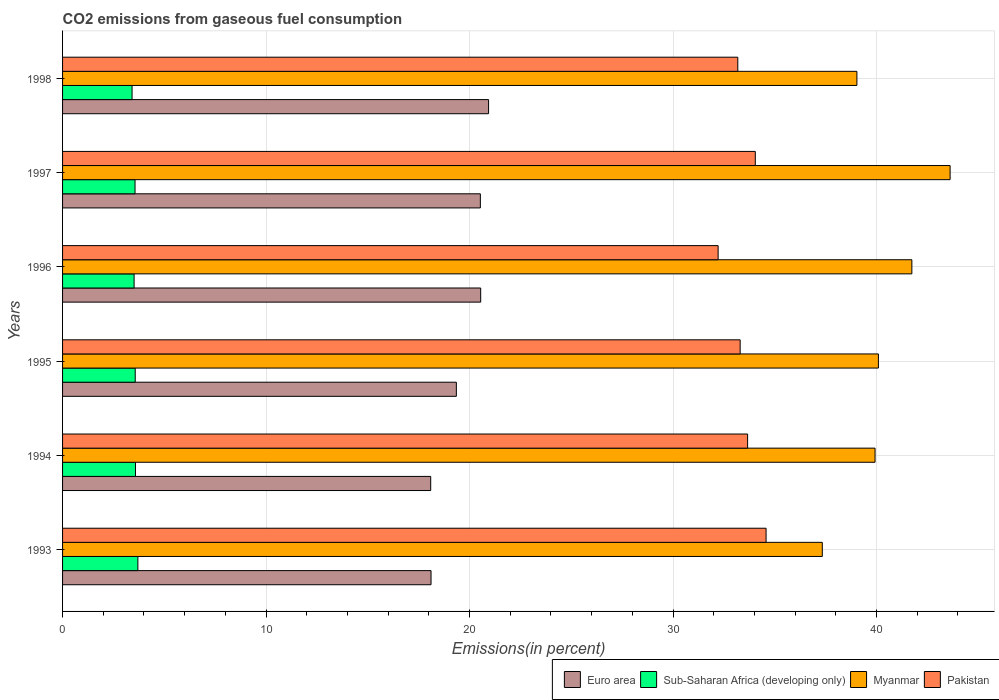Are the number of bars per tick equal to the number of legend labels?
Give a very brief answer. Yes. How many bars are there on the 1st tick from the top?
Provide a succinct answer. 4. What is the total CO2 emitted in Myanmar in 1995?
Offer a very short reply. 40.09. Across all years, what is the maximum total CO2 emitted in Sub-Saharan Africa (developing only)?
Your answer should be very brief. 3.7. Across all years, what is the minimum total CO2 emitted in Euro area?
Offer a very short reply. 18.09. In which year was the total CO2 emitted in Euro area maximum?
Provide a succinct answer. 1998. What is the total total CO2 emitted in Pakistan in the graph?
Your answer should be compact. 200.99. What is the difference between the total CO2 emitted in Myanmar in 1997 and that in 1998?
Keep it short and to the point. 4.58. What is the difference between the total CO2 emitted in Pakistan in 1996 and the total CO2 emitted in Euro area in 1997?
Make the answer very short. 11.69. What is the average total CO2 emitted in Myanmar per year?
Provide a short and direct response. 40.29. In the year 1996, what is the difference between the total CO2 emitted in Sub-Saharan Africa (developing only) and total CO2 emitted in Myanmar?
Keep it short and to the point. -38.22. What is the ratio of the total CO2 emitted in Sub-Saharan Africa (developing only) in 1994 to that in 1997?
Give a very brief answer. 1.01. What is the difference between the highest and the second highest total CO2 emitted in Pakistan?
Ensure brevity in your answer.  0.53. What is the difference between the highest and the lowest total CO2 emitted in Pakistan?
Keep it short and to the point. 2.36. In how many years, is the total CO2 emitted in Myanmar greater than the average total CO2 emitted in Myanmar taken over all years?
Keep it short and to the point. 2. Is the sum of the total CO2 emitted in Pakistan in 1995 and 1998 greater than the maximum total CO2 emitted in Sub-Saharan Africa (developing only) across all years?
Provide a succinct answer. Yes. Is it the case that in every year, the sum of the total CO2 emitted in Sub-Saharan Africa (developing only) and total CO2 emitted in Myanmar is greater than the sum of total CO2 emitted in Euro area and total CO2 emitted in Pakistan?
Keep it short and to the point. No. What does the 3rd bar from the top in 1993 represents?
Ensure brevity in your answer.  Sub-Saharan Africa (developing only). Does the graph contain any zero values?
Offer a terse response. No. Does the graph contain grids?
Your answer should be very brief. Yes. How are the legend labels stacked?
Provide a short and direct response. Horizontal. What is the title of the graph?
Provide a short and direct response. CO2 emissions from gaseous fuel consumption. What is the label or title of the X-axis?
Give a very brief answer. Emissions(in percent). What is the label or title of the Y-axis?
Make the answer very short. Years. What is the Emissions(in percent) of Euro area in 1993?
Provide a short and direct response. 18.11. What is the Emissions(in percent) in Sub-Saharan Africa (developing only) in 1993?
Give a very brief answer. 3.7. What is the Emissions(in percent) of Myanmar in 1993?
Make the answer very short. 37.34. What is the Emissions(in percent) in Pakistan in 1993?
Your answer should be compact. 34.57. What is the Emissions(in percent) of Euro area in 1994?
Offer a very short reply. 18.09. What is the Emissions(in percent) in Sub-Saharan Africa (developing only) in 1994?
Provide a succinct answer. 3.58. What is the Emissions(in percent) in Myanmar in 1994?
Your answer should be very brief. 39.93. What is the Emissions(in percent) in Pakistan in 1994?
Your answer should be very brief. 33.67. What is the Emissions(in percent) of Euro area in 1995?
Provide a short and direct response. 19.35. What is the Emissions(in percent) of Sub-Saharan Africa (developing only) in 1995?
Make the answer very short. 3.57. What is the Emissions(in percent) in Myanmar in 1995?
Ensure brevity in your answer.  40.09. What is the Emissions(in percent) of Pakistan in 1995?
Ensure brevity in your answer.  33.3. What is the Emissions(in percent) of Euro area in 1996?
Keep it short and to the point. 20.55. What is the Emissions(in percent) of Sub-Saharan Africa (developing only) in 1996?
Provide a succinct answer. 3.52. What is the Emissions(in percent) of Myanmar in 1996?
Make the answer very short. 41.74. What is the Emissions(in percent) of Pakistan in 1996?
Your answer should be compact. 32.22. What is the Emissions(in percent) of Euro area in 1997?
Make the answer very short. 20.53. What is the Emissions(in percent) in Sub-Saharan Africa (developing only) in 1997?
Provide a short and direct response. 3.56. What is the Emissions(in percent) in Myanmar in 1997?
Provide a succinct answer. 43.62. What is the Emissions(in percent) in Pakistan in 1997?
Make the answer very short. 34.04. What is the Emissions(in percent) in Euro area in 1998?
Offer a terse response. 20.94. What is the Emissions(in percent) of Sub-Saharan Africa (developing only) in 1998?
Provide a succinct answer. 3.42. What is the Emissions(in percent) of Myanmar in 1998?
Give a very brief answer. 39.04. What is the Emissions(in percent) of Pakistan in 1998?
Offer a very short reply. 33.18. Across all years, what is the maximum Emissions(in percent) of Euro area?
Provide a succinct answer. 20.94. Across all years, what is the maximum Emissions(in percent) in Sub-Saharan Africa (developing only)?
Your answer should be compact. 3.7. Across all years, what is the maximum Emissions(in percent) in Myanmar?
Your response must be concise. 43.62. Across all years, what is the maximum Emissions(in percent) in Pakistan?
Give a very brief answer. 34.57. Across all years, what is the minimum Emissions(in percent) in Euro area?
Make the answer very short. 18.09. Across all years, what is the minimum Emissions(in percent) of Sub-Saharan Africa (developing only)?
Offer a very short reply. 3.42. Across all years, what is the minimum Emissions(in percent) in Myanmar?
Provide a short and direct response. 37.34. Across all years, what is the minimum Emissions(in percent) of Pakistan?
Your response must be concise. 32.22. What is the total Emissions(in percent) of Euro area in the graph?
Ensure brevity in your answer.  117.57. What is the total Emissions(in percent) in Sub-Saharan Africa (developing only) in the graph?
Give a very brief answer. 21.35. What is the total Emissions(in percent) in Myanmar in the graph?
Your response must be concise. 241.76. What is the total Emissions(in percent) of Pakistan in the graph?
Keep it short and to the point. 200.99. What is the difference between the Emissions(in percent) in Euro area in 1993 and that in 1994?
Your response must be concise. 0.02. What is the difference between the Emissions(in percent) of Sub-Saharan Africa (developing only) in 1993 and that in 1994?
Offer a very short reply. 0.12. What is the difference between the Emissions(in percent) in Myanmar in 1993 and that in 1994?
Your answer should be very brief. -2.59. What is the difference between the Emissions(in percent) of Pakistan in 1993 and that in 1994?
Offer a terse response. 0.91. What is the difference between the Emissions(in percent) of Euro area in 1993 and that in 1995?
Keep it short and to the point. -1.24. What is the difference between the Emissions(in percent) of Sub-Saharan Africa (developing only) in 1993 and that in 1995?
Ensure brevity in your answer.  0.13. What is the difference between the Emissions(in percent) of Myanmar in 1993 and that in 1995?
Your answer should be very brief. -2.76. What is the difference between the Emissions(in percent) in Pakistan in 1993 and that in 1995?
Offer a very short reply. 1.27. What is the difference between the Emissions(in percent) of Euro area in 1993 and that in 1996?
Ensure brevity in your answer.  -2.44. What is the difference between the Emissions(in percent) in Sub-Saharan Africa (developing only) in 1993 and that in 1996?
Give a very brief answer. 0.19. What is the difference between the Emissions(in percent) of Myanmar in 1993 and that in 1996?
Your response must be concise. -4.4. What is the difference between the Emissions(in percent) of Pakistan in 1993 and that in 1996?
Your answer should be compact. 2.36. What is the difference between the Emissions(in percent) in Euro area in 1993 and that in 1997?
Offer a very short reply. -2.42. What is the difference between the Emissions(in percent) of Sub-Saharan Africa (developing only) in 1993 and that in 1997?
Give a very brief answer. 0.14. What is the difference between the Emissions(in percent) in Myanmar in 1993 and that in 1997?
Make the answer very short. -6.28. What is the difference between the Emissions(in percent) of Pakistan in 1993 and that in 1997?
Give a very brief answer. 0.53. What is the difference between the Emissions(in percent) of Euro area in 1993 and that in 1998?
Ensure brevity in your answer.  -2.83. What is the difference between the Emissions(in percent) of Sub-Saharan Africa (developing only) in 1993 and that in 1998?
Provide a short and direct response. 0.29. What is the difference between the Emissions(in percent) of Myanmar in 1993 and that in 1998?
Keep it short and to the point. -1.7. What is the difference between the Emissions(in percent) of Pakistan in 1993 and that in 1998?
Your response must be concise. 1.39. What is the difference between the Emissions(in percent) of Euro area in 1994 and that in 1995?
Give a very brief answer. -1.26. What is the difference between the Emissions(in percent) in Sub-Saharan Africa (developing only) in 1994 and that in 1995?
Keep it short and to the point. 0.01. What is the difference between the Emissions(in percent) in Myanmar in 1994 and that in 1995?
Ensure brevity in your answer.  -0.17. What is the difference between the Emissions(in percent) of Pakistan in 1994 and that in 1995?
Offer a very short reply. 0.37. What is the difference between the Emissions(in percent) in Euro area in 1994 and that in 1996?
Offer a very short reply. -2.46. What is the difference between the Emissions(in percent) in Sub-Saharan Africa (developing only) in 1994 and that in 1996?
Provide a short and direct response. 0.07. What is the difference between the Emissions(in percent) of Myanmar in 1994 and that in 1996?
Your answer should be very brief. -1.81. What is the difference between the Emissions(in percent) of Pakistan in 1994 and that in 1996?
Your answer should be compact. 1.45. What is the difference between the Emissions(in percent) in Euro area in 1994 and that in 1997?
Make the answer very short. -2.44. What is the difference between the Emissions(in percent) in Sub-Saharan Africa (developing only) in 1994 and that in 1997?
Offer a very short reply. 0.02. What is the difference between the Emissions(in percent) in Myanmar in 1994 and that in 1997?
Offer a very short reply. -3.69. What is the difference between the Emissions(in percent) of Pakistan in 1994 and that in 1997?
Give a very brief answer. -0.38. What is the difference between the Emissions(in percent) in Euro area in 1994 and that in 1998?
Make the answer very short. -2.84. What is the difference between the Emissions(in percent) in Sub-Saharan Africa (developing only) in 1994 and that in 1998?
Your answer should be compact. 0.17. What is the difference between the Emissions(in percent) of Myanmar in 1994 and that in 1998?
Keep it short and to the point. 0.89. What is the difference between the Emissions(in percent) in Pakistan in 1994 and that in 1998?
Your answer should be compact. 0.48. What is the difference between the Emissions(in percent) of Euro area in 1995 and that in 1996?
Your response must be concise. -1.2. What is the difference between the Emissions(in percent) of Sub-Saharan Africa (developing only) in 1995 and that in 1996?
Your response must be concise. 0.05. What is the difference between the Emissions(in percent) in Myanmar in 1995 and that in 1996?
Give a very brief answer. -1.64. What is the difference between the Emissions(in percent) in Pakistan in 1995 and that in 1996?
Your answer should be very brief. 1.08. What is the difference between the Emissions(in percent) of Euro area in 1995 and that in 1997?
Make the answer very short. -1.18. What is the difference between the Emissions(in percent) of Sub-Saharan Africa (developing only) in 1995 and that in 1997?
Ensure brevity in your answer.  0.01. What is the difference between the Emissions(in percent) of Myanmar in 1995 and that in 1997?
Provide a short and direct response. -3.52. What is the difference between the Emissions(in percent) in Pakistan in 1995 and that in 1997?
Your answer should be very brief. -0.74. What is the difference between the Emissions(in percent) in Euro area in 1995 and that in 1998?
Your answer should be compact. -1.58. What is the difference between the Emissions(in percent) of Sub-Saharan Africa (developing only) in 1995 and that in 1998?
Offer a terse response. 0.15. What is the difference between the Emissions(in percent) in Myanmar in 1995 and that in 1998?
Provide a succinct answer. 1.06. What is the difference between the Emissions(in percent) of Pakistan in 1995 and that in 1998?
Make the answer very short. 0.12. What is the difference between the Emissions(in percent) of Euro area in 1996 and that in 1997?
Offer a very short reply. 0.02. What is the difference between the Emissions(in percent) in Sub-Saharan Africa (developing only) in 1996 and that in 1997?
Ensure brevity in your answer.  -0.05. What is the difference between the Emissions(in percent) in Myanmar in 1996 and that in 1997?
Give a very brief answer. -1.88. What is the difference between the Emissions(in percent) in Pakistan in 1996 and that in 1997?
Keep it short and to the point. -1.83. What is the difference between the Emissions(in percent) in Euro area in 1996 and that in 1998?
Provide a succinct answer. -0.39. What is the difference between the Emissions(in percent) of Sub-Saharan Africa (developing only) in 1996 and that in 1998?
Keep it short and to the point. 0.1. What is the difference between the Emissions(in percent) of Myanmar in 1996 and that in 1998?
Ensure brevity in your answer.  2.7. What is the difference between the Emissions(in percent) in Pakistan in 1996 and that in 1998?
Your response must be concise. -0.97. What is the difference between the Emissions(in percent) in Euro area in 1997 and that in 1998?
Make the answer very short. -0.4. What is the difference between the Emissions(in percent) of Sub-Saharan Africa (developing only) in 1997 and that in 1998?
Your response must be concise. 0.15. What is the difference between the Emissions(in percent) of Myanmar in 1997 and that in 1998?
Provide a succinct answer. 4.58. What is the difference between the Emissions(in percent) of Pakistan in 1997 and that in 1998?
Provide a short and direct response. 0.86. What is the difference between the Emissions(in percent) in Euro area in 1993 and the Emissions(in percent) in Sub-Saharan Africa (developing only) in 1994?
Keep it short and to the point. 14.52. What is the difference between the Emissions(in percent) in Euro area in 1993 and the Emissions(in percent) in Myanmar in 1994?
Provide a succinct answer. -21.82. What is the difference between the Emissions(in percent) of Euro area in 1993 and the Emissions(in percent) of Pakistan in 1994?
Keep it short and to the point. -15.56. What is the difference between the Emissions(in percent) in Sub-Saharan Africa (developing only) in 1993 and the Emissions(in percent) in Myanmar in 1994?
Provide a short and direct response. -36.23. What is the difference between the Emissions(in percent) in Sub-Saharan Africa (developing only) in 1993 and the Emissions(in percent) in Pakistan in 1994?
Your answer should be compact. -29.96. What is the difference between the Emissions(in percent) in Myanmar in 1993 and the Emissions(in percent) in Pakistan in 1994?
Provide a short and direct response. 3.67. What is the difference between the Emissions(in percent) of Euro area in 1993 and the Emissions(in percent) of Sub-Saharan Africa (developing only) in 1995?
Offer a terse response. 14.54. What is the difference between the Emissions(in percent) of Euro area in 1993 and the Emissions(in percent) of Myanmar in 1995?
Make the answer very short. -21.99. What is the difference between the Emissions(in percent) of Euro area in 1993 and the Emissions(in percent) of Pakistan in 1995?
Provide a short and direct response. -15.19. What is the difference between the Emissions(in percent) in Sub-Saharan Africa (developing only) in 1993 and the Emissions(in percent) in Myanmar in 1995?
Keep it short and to the point. -36.39. What is the difference between the Emissions(in percent) of Sub-Saharan Africa (developing only) in 1993 and the Emissions(in percent) of Pakistan in 1995?
Your response must be concise. -29.6. What is the difference between the Emissions(in percent) in Myanmar in 1993 and the Emissions(in percent) in Pakistan in 1995?
Make the answer very short. 4.04. What is the difference between the Emissions(in percent) in Euro area in 1993 and the Emissions(in percent) in Sub-Saharan Africa (developing only) in 1996?
Provide a short and direct response. 14.59. What is the difference between the Emissions(in percent) of Euro area in 1993 and the Emissions(in percent) of Myanmar in 1996?
Provide a short and direct response. -23.63. What is the difference between the Emissions(in percent) of Euro area in 1993 and the Emissions(in percent) of Pakistan in 1996?
Provide a short and direct response. -14.11. What is the difference between the Emissions(in percent) in Sub-Saharan Africa (developing only) in 1993 and the Emissions(in percent) in Myanmar in 1996?
Make the answer very short. -38.04. What is the difference between the Emissions(in percent) in Sub-Saharan Africa (developing only) in 1993 and the Emissions(in percent) in Pakistan in 1996?
Give a very brief answer. -28.52. What is the difference between the Emissions(in percent) in Myanmar in 1993 and the Emissions(in percent) in Pakistan in 1996?
Provide a short and direct response. 5.12. What is the difference between the Emissions(in percent) of Euro area in 1993 and the Emissions(in percent) of Sub-Saharan Africa (developing only) in 1997?
Ensure brevity in your answer.  14.55. What is the difference between the Emissions(in percent) of Euro area in 1993 and the Emissions(in percent) of Myanmar in 1997?
Your answer should be compact. -25.51. What is the difference between the Emissions(in percent) in Euro area in 1993 and the Emissions(in percent) in Pakistan in 1997?
Keep it short and to the point. -15.94. What is the difference between the Emissions(in percent) of Sub-Saharan Africa (developing only) in 1993 and the Emissions(in percent) of Myanmar in 1997?
Keep it short and to the point. -39.92. What is the difference between the Emissions(in percent) of Sub-Saharan Africa (developing only) in 1993 and the Emissions(in percent) of Pakistan in 1997?
Provide a succinct answer. -30.34. What is the difference between the Emissions(in percent) of Myanmar in 1993 and the Emissions(in percent) of Pakistan in 1997?
Your response must be concise. 3.29. What is the difference between the Emissions(in percent) in Euro area in 1993 and the Emissions(in percent) in Sub-Saharan Africa (developing only) in 1998?
Offer a terse response. 14.69. What is the difference between the Emissions(in percent) in Euro area in 1993 and the Emissions(in percent) in Myanmar in 1998?
Your answer should be very brief. -20.93. What is the difference between the Emissions(in percent) in Euro area in 1993 and the Emissions(in percent) in Pakistan in 1998?
Offer a terse response. -15.08. What is the difference between the Emissions(in percent) of Sub-Saharan Africa (developing only) in 1993 and the Emissions(in percent) of Myanmar in 1998?
Keep it short and to the point. -35.34. What is the difference between the Emissions(in percent) in Sub-Saharan Africa (developing only) in 1993 and the Emissions(in percent) in Pakistan in 1998?
Make the answer very short. -29.48. What is the difference between the Emissions(in percent) of Myanmar in 1993 and the Emissions(in percent) of Pakistan in 1998?
Make the answer very short. 4.15. What is the difference between the Emissions(in percent) in Euro area in 1994 and the Emissions(in percent) in Sub-Saharan Africa (developing only) in 1995?
Provide a succinct answer. 14.52. What is the difference between the Emissions(in percent) in Euro area in 1994 and the Emissions(in percent) in Myanmar in 1995?
Ensure brevity in your answer.  -22. What is the difference between the Emissions(in percent) in Euro area in 1994 and the Emissions(in percent) in Pakistan in 1995?
Keep it short and to the point. -15.21. What is the difference between the Emissions(in percent) in Sub-Saharan Africa (developing only) in 1994 and the Emissions(in percent) in Myanmar in 1995?
Your answer should be very brief. -36.51. What is the difference between the Emissions(in percent) of Sub-Saharan Africa (developing only) in 1994 and the Emissions(in percent) of Pakistan in 1995?
Your response must be concise. -29.72. What is the difference between the Emissions(in percent) of Myanmar in 1994 and the Emissions(in percent) of Pakistan in 1995?
Offer a terse response. 6.63. What is the difference between the Emissions(in percent) in Euro area in 1994 and the Emissions(in percent) in Sub-Saharan Africa (developing only) in 1996?
Your answer should be very brief. 14.58. What is the difference between the Emissions(in percent) of Euro area in 1994 and the Emissions(in percent) of Myanmar in 1996?
Give a very brief answer. -23.65. What is the difference between the Emissions(in percent) of Euro area in 1994 and the Emissions(in percent) of Pakistan in 1996?
Provide a short and direct response. -14.13. What is the difference between the Emissions(in percent) in Sub-Saharan Africa (developing only) in 1994 and the Emissions(in percent) in Myanmar in 1996?
Your response must be concise. -38.16. What is the difference between the Emissions(in percent) in Sub-Saharan Africa (developing only) in 1994 and the Emissions(in percent) in Pakistan in 1996?
Give a very brief answer. -28.63. What is the difference between the Emissions(in percent) of Myanmar in 1994 and the Emissions(in percent) of Pakistan in 1996?
Your answer should be compact. 7.71. What is the difference between the Emissions(in percent) in Euro area in 1994 and the Emissions(in percent) in Sub-Saharan Africa (developing only) in 1997?
Your response must be concise. 14.53. What is the difference between the Emissions(in percent) in Euro area in 1994 and the Emissions(in percent) in Myanmar in 1997?
Give a very brief answer. -25.53. What is the difference between the Emissions(in percent) in Euro area in 1994 and the Emissions(in percent) in Pakistan in 1997?
Keep it short and to the point. -15.95. What is the difference between the Emissions(in percent) of Sub-Saharan Africa (developing only) in 1994 and the Emissions(in percent) of Myanmar in 1997?
Keep it short and to the point. -40.04. What is the difference between the Emissions(in percent) in Sub-Saharan Africa (developing only) in 1994 and the Emissions(in percent) in Pakistan in 1997?
Your answer should be very brief. -30.46. What is the difference between the Emissions(in percent) of Myanmar in 1994 and the Emissions(in percent) of Pakistan in 1997?
Your answer should be very brief. 5.89. What is the difference between the Emissions(in percent) of Euro area in 1994 and the Emissions(in percent) of Sub-Saharan Africa (developing only) in 1998?
Offer a very short reply. 14.68. What is the difference between the Emissions(in percent) of Euro area in 1994 and the Emissions(in percent) of Myanmar in 1998?
Keep it short and to the point. -20.95. What is the difference between the Emissions(in percent) of Euro area in 1994 and the Emissions(in percent) of Pakistan in 1998?
Offer a terse response. -15.09. What is the difference between the Emissions(in percent) in Sub-Saharan Africa (developing only) in 1994 and the Emissions(in percent) in Myanmar in 1998?
Provide a short and direct response. -35.45. What is the difference between the Emissions(in percent) of Sub-Saharan Africa (developing only) in 1994 and the Emissions(in percent) of Pakistan in 1998?
Offer a very short reply. -29.6. What is the difference between the Emissions(in percent) in Myanmar in 1994 and the Emissions(in percent) in Pakistan in 1998?
Offer a very short reply. 6.75. What is the difference between the Emissions(in percent) in Euro area in 1995 and the Emissions(in percent) in Sub-Saharan Africa (developing only) in 1996?
Ensure brevity in your answer.  15.84. What is the difference between the Emissions(in percent) of Euro area in 1995 and the Emissions(in percent) of Myanmar in 1996?
Give a very brief answer. -22.39. What is the difference between the Emissions(in percent) of Euro area in 1995 and the Emissions(in percent) of Pakistan in 1996?
Give a very brief answer. -12.86. What is the difference between the Emissions(in percent) of Sub-Saharan Africa (developing only) in 1995 and the Emissions(in percent) of Myanmar in 1996?
Your response must be concise. -38.17. What is the difference between the Emissions(in percent) in Sub-Saharan Africa (developing only) in 1995 and the Emissions(in percent) in Pakistan in 1996?
Give a very brief answer. -28.65. What is the difference between the Emissions(in percent) of Myanmar in 1995 and the Emissions(in percent) of Pakistan in 1996?
Give a very brief answer. 7.88. What is the difference between the Emissions(in percent) of Euro area in 1995 and the Emissions(in percent) of Sub-Saharan Africa (developing only) in 1997?
Provide a short and direct response. 15.79. What is the difference between the Emissions(in percent) in Euro area in 1995 and the Emissions(in percent) in Myanmar in 1997?
Give a very brief answer. -24.27. What is the difference between the Emissions(in percent) in Euro area in 1995 and the Emissions(in percent) in Pakistan in 1997?
Give a very brief answer. -14.69. What is the difference between the Emissions(in percent) of Sub-Saharan Africa (developing only) in 1995 and the Emissions(in percent) of Myanmar in 1997?
Keep it short and to the point. -40.05. What is the difference between the Emissions(in percent) in Sub-Saharan Africa (developing only) in 1995 and the Emissions(in percent) in Pakistan in 1997?
Provide a short and direct response. -30.47. What is the difference between the Emissions(in percent) in Myanmar in 1995 and the Emissions(in percent) in Pakistan in 1997?
Your answer should be compact. 6.05. What is the difference between the Emissions(in percent) of Euro area in 1995 and the Emissions(in percent) of Sub-Saharan Africa (developing only) in 1998?
Ensure brevity in your answer.  15.94. What is the difference between the Emissions(in percent) of Euro area in 1995 and the Emissions(in percent) of Myanmar in 1998?
Offer a very short reply. -19.68. What is the difference between the Emissions(in percent) of Euro area in 1995 and the Emissions(in percent) of Pakistan in 1998?
Provide a short and direct response. -13.83. What is the difference between the Emissions(in percent) in Sub-Saharan Africa (developing only) in 1995 and the Emissions(in percent) in Myanmar in 1998?
Your response must be concise. -35.47. What is the difference between the Emissions(in percent) in Sub-Saharan Africa (developing only) in 1995 and the Emissions(in percent) in Pakistan in 1998?
Your answer should be compact. -29.61. What is the difference between the Emissions(in percent) in Myanmar in 1995 and the Emissions(in percent) in Pakistan in 1998?
Offer a very short reply. 6.91. What is the difference between the Emissions(in percent) in Euro area in 1996 and the Emissions(in percent) in Sub-Saharan Africa (developing only) in 1997?
Provide a succinct answer. 16.99. What is the difference between the Emissions(in percent) in Euro area in 1996 and the Emissions(in percent) in Myanmar in 1997?
Your response must be concise. -23.07. What is the difference between the Emissions(in percent) of Euro area in 1996 and the Emissions(in percent) of Pakistan in 1997?
Make the answer very short. -13.5. What is the difference between the Emissions(in percent) of Sub-Saharan Africa (developing only) in 1996 and the Emissions(in percent) of Myanmar in 1997?
Offer a very short reply. -40.1. What is the difference between the Emissions(in percent) of Sub-Saharan Africa (developing only) in 1996 and the Emissions(in percent) of Pakistan in 1997?
Keep it short and to the point. -30.53. What is the difference between the Emissions(in percent) of Myanmar in 1996 and the Emissions(in percent) of Pakistan in 1997?
Your answer should be very brief. 7.69. What is the difference between the Emissions(in percent) of Euro area in 1996 and the Emissions(in percent) of Sub-Saharan Africa (developing only) in 1998?
Make the answer very short. 17.13. What is the difference between the Emissions(in percent) in Euro area in 1996 and the Emissions(in percent) in Myanmar in 1998?
Make the answer very short. -18.49. What is the difference between the Emissions(in percent) in Euro area in 1996 and the Emissions(in percent) in Pakistan in 1998?
Offer a very short reply. -12.64. What is the difference between the Emissions(in percent) of Sub-Saharan Africa (developing only) in 1996 and the Emissions(in percent) of Myanmar in 1998?
Your answer should be compact. -35.52. What is the difference between the Emissions(in percent) of Sub-Saharan Africa (developing only) in 1996 and the Emissions(in percent) of Pakistan in 1998?
Offer a very short reply. -29.67. What is the difference between the Emissions(in percent) of Myanmar in 1996 and the Emissions(in percent) of Pakistan in 1998?
Provide a short and direct response. 8.55. What is the difference between the Emissions(in percent) of Euro area in 1997 and the Emissions(in percent) of Sub-Saharan Africa (developing only) in 1998?
Provide a succinct answer. 17.12. What is the difference between the Emissions(in percent) in Euro area in 1997 and the Emissions(in percent) in Myanmar in 1998?
Provide a short and direct response. -18.51. What is the difference between the Emissions(in percent) of Euro area in 1997 and the Emissions(in percent) of Pakistan in 1998?
Provide a short and direct response. -12.65. What is the difference between the Emissions(in percent) of Sub-Saharan Africa (developing only) in 1997 and the Emissions(in percent) of Myanmar in 1998?
Your response must be concise. -35.48. What is the difference between the Emissions(in percent) of Sub-Saharan Africa (developing only) in 1997 and the Emissions(in percent) of Pakistan in 1998?
Offer a terse response. -29.62. What is the difference between the Emissions(in percent) in Myanmar in 1997 and the Emissions(in percent) in Pakistan in 1998?
Provide a short and direct response. 10.43. What is the average Emissions(in percent) in Euro area per year?
Ensure brevity in your answer.  19.59. What is the average Emissions(in percent) of Sub-Saharan Africa (developing only) per year?
Give a very brief answer. 3.56. What is the average Emissions(in percent) of Myanmar per year?
Provide a succinct answer. 40.29. What is the average Emissions(in percent) in Pakistan per year?
Your answer should be very brief. 33.5. In the year 1993, what is the difference between the Emissions(in percent) in Euro area and Emissions(in percent) in Sub-Saharan Africa (developing only)?
Your answer should be very brief. 14.41. In the year 1993, what is the difference between the Emissions(in percent) in Euro area and Emissions(in percent) in Myanmar?
Provide a succinct answer. -19.23. In the year 1993, what is the difference between the Emissions(in percent) of Euro area and Emissions(in percent) of Pakistan?
Your response must be concise. -16.47. In the year 1993, what is the difference between the Emissions(in percent) in Sub-Saharan Africa (developing only) and Emissions(in percent) in Myanmar?
Provide a short and direct response. -33.64. In the year 1993, what is the difference between the Emissions(in percent) of Sub-Saharan Africa (developing only) and Emissions(in percent) of Pakistan?
Offer a very short reply. -30.87. In the year 1993, what is the difference between the Emissions(in percent) in Myanmar and Emissions(in percent) in Pakistan?
Your answer should be very brief. 2.76. In the year 1994, what is the difference between the Emissions(in percent) in Euro area and Emissions(in percent) in Sub-Saharan Africa (developing only)?
Your answer should be compact. 14.51. In the year 1994, what is the difference between the Emissions(in percent) in Euro area and Emissions(in percent) in Myanmar?
Provide a succinct answer. -21.84. In the year 1994, what is the difference between the Emissions(in percent) of Euro area and Emissions(in percent) of Pakistan?
Your response must be concise. -15.57. In the year 1994, what is the difference between the Emissions(in percent) in Sub-Saharan Africa (developing only) and Emissions(in percent) in Myanmar?
Keep it short and to the point. -36.35. In the year 1994, what is the difference between the Emissions(in percent) of Sub-Saharan Africa (developing only) and Emissions(in percent) of Pakistan?
Provide a short and direct response. -30.08. In the year 1994, what is the difference between the Emissions(in percent) of Myanmar and Emissions(in percent) of Pakistan?
Offer a very short reply. 6.26. In the year 1995, what is the difference between the Emissions(in percent) in Euro area and Emissions(in percent) in Sub-Saharan Africa (developing only)?
Your response must be concise. 15.78. In the year 1995, what is the difference between the Emissions(in percent) of Euro area and Emissions(in percent) of Myanmar?
Offer a very short reply. -20.74. In the year 1995, what is the difference between the Emissions(in percent) in Euro area and Emissions(in percent) in Pakistan?
Make the answer very short. -13.95. In the year 1995, what is the difference between the Emissions(in percent) of Sub-Saharan Africa (developing only) and Emissions(in percent) of Myanmar?
Keep it short and to the point. -36.52. In the year 1995, what is the difference between the Emissions(in percent) in Sub-Saharan Africa (developing only) and Emissions(in percent) in Pakistan?
Your answer should be very brief. -29.73. In the year 1995, what is the difference between the Emissions(in percent) in Myanmar and Emissions(in percent) in Pakistan?
Offer a very short reply. 6.79. In the year 1996, what is the difference between the Emissions(in percent) of Euro area and Emissions(in percent) of Sub-Saharan Africa (developing only)?
Your response must be concise. 17.03. In the year 1996, what is the difference between the Emissions(in percent) in Euro area and Emissions(in percent) in Myanmar?
Ensure brevity in your answer.  -21.19. In the year 1996, what is the difference between the Emissions(in percent) in Euro area and Emissions(in percent) in Pakistan?
Your response must be concise. -11.67. In the year 1996, what is the difference between the Emissions(in percent) of Sub-Saharan Africa (developing only) and Emissions(in percent) of Myanmar?
Provide a succinct answer. -38.22. In the year 1996, what is the difference between the Emissions(in percent) of Sub-Saharan Africa (developing only) and Emissions(in percent) of Pakistan?
Your answer should be very brief. -28.7. In the year 1996, what is the difference between the Emissions(in percent) in Myanmar and Emissions(in percent) in Pakistan?
Make the answer very short. 9.52. In the year 1997, what is the difference between the Emissions(in percent) of Euro area and Emissions(in percent) of Sub-Saharan Africa (developing only)?
Keep it short and to the point. 16.97. In the year 1997, what is the difference between the Emissions(in percent) in Euro area and Emissions(in percent) in Myanmar?
Provide a short and direct response. -23.09. In the year 1997, what is the difference between the Emissions(in percent) of Euro area and Emissions(in percent) of Pakistan?
Offer a very short reply. -13.51. In the year 1997, what is the difference between the Emissions(in percent) of Sub-Saharan Africa (developing only) and Emissions(in percent) of Myanmar?
Your response must be concise. -40.06. In the year 1997, what is the difference between the Emissions(in percent) in Sub-Saharan Africa (developing only) and Emissions(in percent) in Pakistan?
Provide a succinct answer. -30.48. In the year 1997, what is the difference between the Emissions(in percent) of Myanmar and Emissions(in percent) of Pakistan?
Your answer should be very brief. 9.57. In the year 1998, what is the difference between the Emissions(in percent) of Euro area and Emissions(in percent) of Sub-Saharan Africa (developing only)?
Ensure brevity in your answer.  17.52. In the year 1998, what is the difference between the Emissions(in percent) of Euro area and Emissions(in percent) of Myanmar?
Offer a terse response. -18.1. In the year 1998, what is the difference between the Emissions(in percent) of Euro area and Emissions(in percent) of Pakistan?
Provide a succinct answer. -12.25. In the year 1998, what is the difference between the Emissions(in percent) of Sub-Saharan Africa (developing only) and Emissions(in percent) of Myanmar?
Provide a short and direct response. -35.62. In the year 1998, what is the difference between the Emissions(in percent) in Sub-Saharan Africa (developing only) and Emissions(in percent) in Pakistan?
Your answer should be compact. -29.77. In the year 1998, what is the difference between the Emissions(in percent) of Myanmar and Emissions(in percent) of Pakistan?
Make the answer very short. 5.85. What is the ratio of the Emissions(in percent) of Sub-Saharan Africa (developing only) in 1993 to that in 1994?
Keep it short and to the point. 1.03. What is the ratio of the Emissions(in percent) of Myanmar in 1993 to that in 1994?
Make the answer very short. 0.94. What is the ratio of the Emissions(in percent) of Pakistan in 1993 to that in 1994?
Give a very brief answer. 1.03. What is the ratio of the Emissions(in percent) of Euro area in 1993 to that in 1995?
Make the answer very short. 0.94. What is the ratio of the Emissions(in percent) in Sub-Saharan Africa (developing only) in 1993 to that in 1995?
Provide a short and direct response. 1.04. What is the ratio of the Emissions(in percent) in Myanmar in 1993 to that in 1995?
Offer a very short reply. 0.93. What is the ratio of the Emissions(in percent) of Pakistan in 1993 to that in 1995?
Your answer should be compact. 1.04. What is the ratio of the Emissions(in percent) of Euro area in 1993 to that in 1996?
Offer a very short reply. 0.88. What is the ratio of the Emissions(in percent) in Sub-Saharan Africa (developing only) in 1993 to that in 1996?
Your answer should be compact. 1.05. What is the ratio of the Emissions(in percent) in Myanmar in 1993 to that in 1996?
Provide a succinct answer. 0.89. What is the ratio of the Emissions(in percent) in Pakistan in 1993 to that in 1996?
Your response must be concise. 1.07. What is the ratio of the Emissions(in percent) of Euro area in 1993 to that in 1997?
Give a very brief answer. 0.88. What is the ratio of the Emissions(in percent) in Sub-Saharan Africa (developing only) in 1993 to that in 1997?
Provide a short and direct response. 1.04. What is the ratio of the Emissions(in percent) in Myanmar in 1993 to that in 1997?
Your answer should be very brief. 0.86. What is the ratio of the Emissions(in percent) of Pakistan in 1993 to that in 1997?
Your answer should be compact. 1.02. What is the ratio of the Emissions(in percent) of Euro area in 1993 to that in 1998?
Keep it short and to the point. 0.86. What is the ratio of the Emissions(in percent) in Sub-Saharan Africa (developing only) in 1993 to that in 1998?
Your response must be concise. 1.08. What is the ratio of the Emissions(in percent) of Myanmar in 1993 to that in 1998?
Your answer should be compact. 0.96. What is the ratio of the Emissions(in percent) of Pakistan in 1993 to that in 1998?
Keep it short and to the point. 1.04. What is the ratio of the Emissions(in percent) of Euro area in 1994 to that in 1995?
Your answer should be compact. 0.93. What is the ratio of the Emissions(in percent) in Pakistan in 1994 to that in 1995?
Your answer should be very brief. 1.01. What is the ratio of the Emissions(in percent) in Euro area in 1994 to that in 1996?
Ensure brevity in your answer.  0.88. What is the ratio of the Emissions(in percent) in Sub-Saharan Africa (developing only) in 1994 to that in 1996?
Your response must be concise. 1.02. What is the ratio of the Emissions(in percent) of Myanmar in 1994 to that in 1996?
Give a very brief answer. 0.96. What is the ratio of the Emissions(in percent) of Pakistan in 1994 to that in 1996?
Your answer should be very brief. 1.04. What is the ratio of the Emissions(in percent) in Euro area in 1994 to that in 1997?
Offer a very short reply. 0.88. What is the ratio of the Emissions(in percent) in Sub-Saharan Africa (developing only) in 1994 to that in 1997?
Offer a very short reply. 1.01. What is the ratio of the Emissions(in percent) of Myanmar in 1994 to that in 1997?
Keep it short and to the point. 0.92. What is the ratio of the Emissions(in percent) in Pakistan in 1994 to that in 1997?
Offer a very short reply. 0.99. What is the ratio of the Emissions(in percent) of Euro area in 1994 to that in 1998?
Offer a terse response. 0.86. What is the ratio of the Emissions(in percent) of Sub-Saharan Africa (developing only) in 1994 to that in 1998?
Your answer should be very brief. 1.05. What is the ratio of the Emissions(in percent) in Myanmar in 1994 to that in 1998?
Make the answer very short. 1.02. What is the ratio of the Emissions(in percent) of Pakistan in 1994 to that in 1998?
Your answer should be very brief. 1.01. What is the ratio of the Emissions(in percent) of Euro area in 1995 to that in 1996?
Ensure brevity in your answer.  0.94. What is the ratio of the Emissions(in percent) of Sub-Saharan Africa (developing only) in 1995 to that in 1996?
Make the answer very short. 1.02. What is the ratio of the Emissions(in percent) in Myanmar in 1995 to that in 1996?
Keep it short and to the point. 0.96. What is the ratio of the Emissions(in percent) of Pakistan in 1995 to that in 1996?
Offer a very short reply. 1.03. What is the ratio of the Emissions(in percent) of Euro area in 1995 to that in 1997?
Provide a succinct answer. 0.94. What is the ratio of the Emissions(in percent) in Sub-Saharan Africa (developing only) in 1995 to that in 1997?
Ensure brevity in your answer.  1. What is the ratio of the Emissions(in percent) in Myanmar in 1995 to that in 1997?
Keep it short and to the point. 0.92. What is the ratio of the Emissions(in percent) of Pakistan in 1995 to that in 1997?
Offer a terse response. 0.98. What is the ratio of the Emissions(in percent) of Euro area in 1995 to that in 1998?
Keep it short and to the point. 0.92. What is the ratio of the Emissions(in percent) of Sub-Saharan Africa (developing only) in 1995 to that in 1998?
Your answer should be compact. 1.05. What is the ratio of the Emissions(in percent) of Myanmar in 1995 to that in 1998?
Keep it short and to the point. 1.03. What is the ratio of the Emissions(in percent) of Pakistan in 1995 to that in 1998?
Offer a terse response. 1. What is the ratio of the Emissions(in percent) in Sub-Saharan Africa (developing only) in 1996 to that in 1997?
Provide a short and direct response. 0.99. What is the ratio of the Emissions(in percent) in Myanmar in 1996 to that in 1997?
Your answer should be very brief. 0.96. What is the ratio of the Emissions(in percent) in Pakistan in 1996 to that in 1997?
Offer a terse response. 0.95. What is the ratio of the Emissions(in percent) in Euro area in 1996 to that in 1998?
Make the answer very short. 0.98. What is the ratio of the Emissions(in percent) in Sub-Saharan Africa (developing only) in 1996 to that in 1998?
Offer a terse response. 1.03. What is the ratio of the Emissions(in percent) of Myanmar in 1996 to that in 1998?
Provide a succinct answer. 1.07. What is the ratio of the Emissions(in percent) of Pakistan in 1996 to that in 1998?
Make the answer very short. 0.97. What is the ratio of the Emissions(in percent) in Euro area in 1997 to that in 1998?
Provide a short and direct response. 0.98. What is the ratio of the Emissions(in percent) in Sub-Saharan Africa (developing only) in 1997 to that in 1998?
Keep it short and to the point. 1.04. What is the ratio of the Emissions(in percent) in Myanmar in 1997 to that in 1998?
Provide a short and direct response. 1.12. What is the ratio of the Emissions(in percent) in Pakistan in 1997 to that in 1998?
Offer a terse response. 1.03. What is the difference between the highest and the second highest Emissions(in percent) of Euro area?
Ensure brevity in your answer.  0.39. What is the difference between the highest and the second highest Emissions(in percent) of Sub-Saharan Africa (developing only)?
Your response must be concise. 0.12. What is the difference between the highest and the second highest Emissions(in percent) of Myanmar?
Keep it short and to the point. 1.88. What is the difference between the highest and the second highest Emissions(in percent) of Pakistan?
Your answer should be very brief. 0.53. What is the difference between the highest and the lowest Emissions(in percent) in Euro area?
Provide a short and direct response. 2.84. What is the difference between the highest and the lowest Emissions(in percent) of Sub-Saharan Africa (developing only)?
Give a very brief answer. 0.29. What is the difference between the highest and the lowest Emissions(in percent) of Myanmar?
Provide a succinct answer. 6.28. What is the difference between the highest and the lowest Emissions(in percent) of Pakistan?
Make the answer very short. 2.36. 